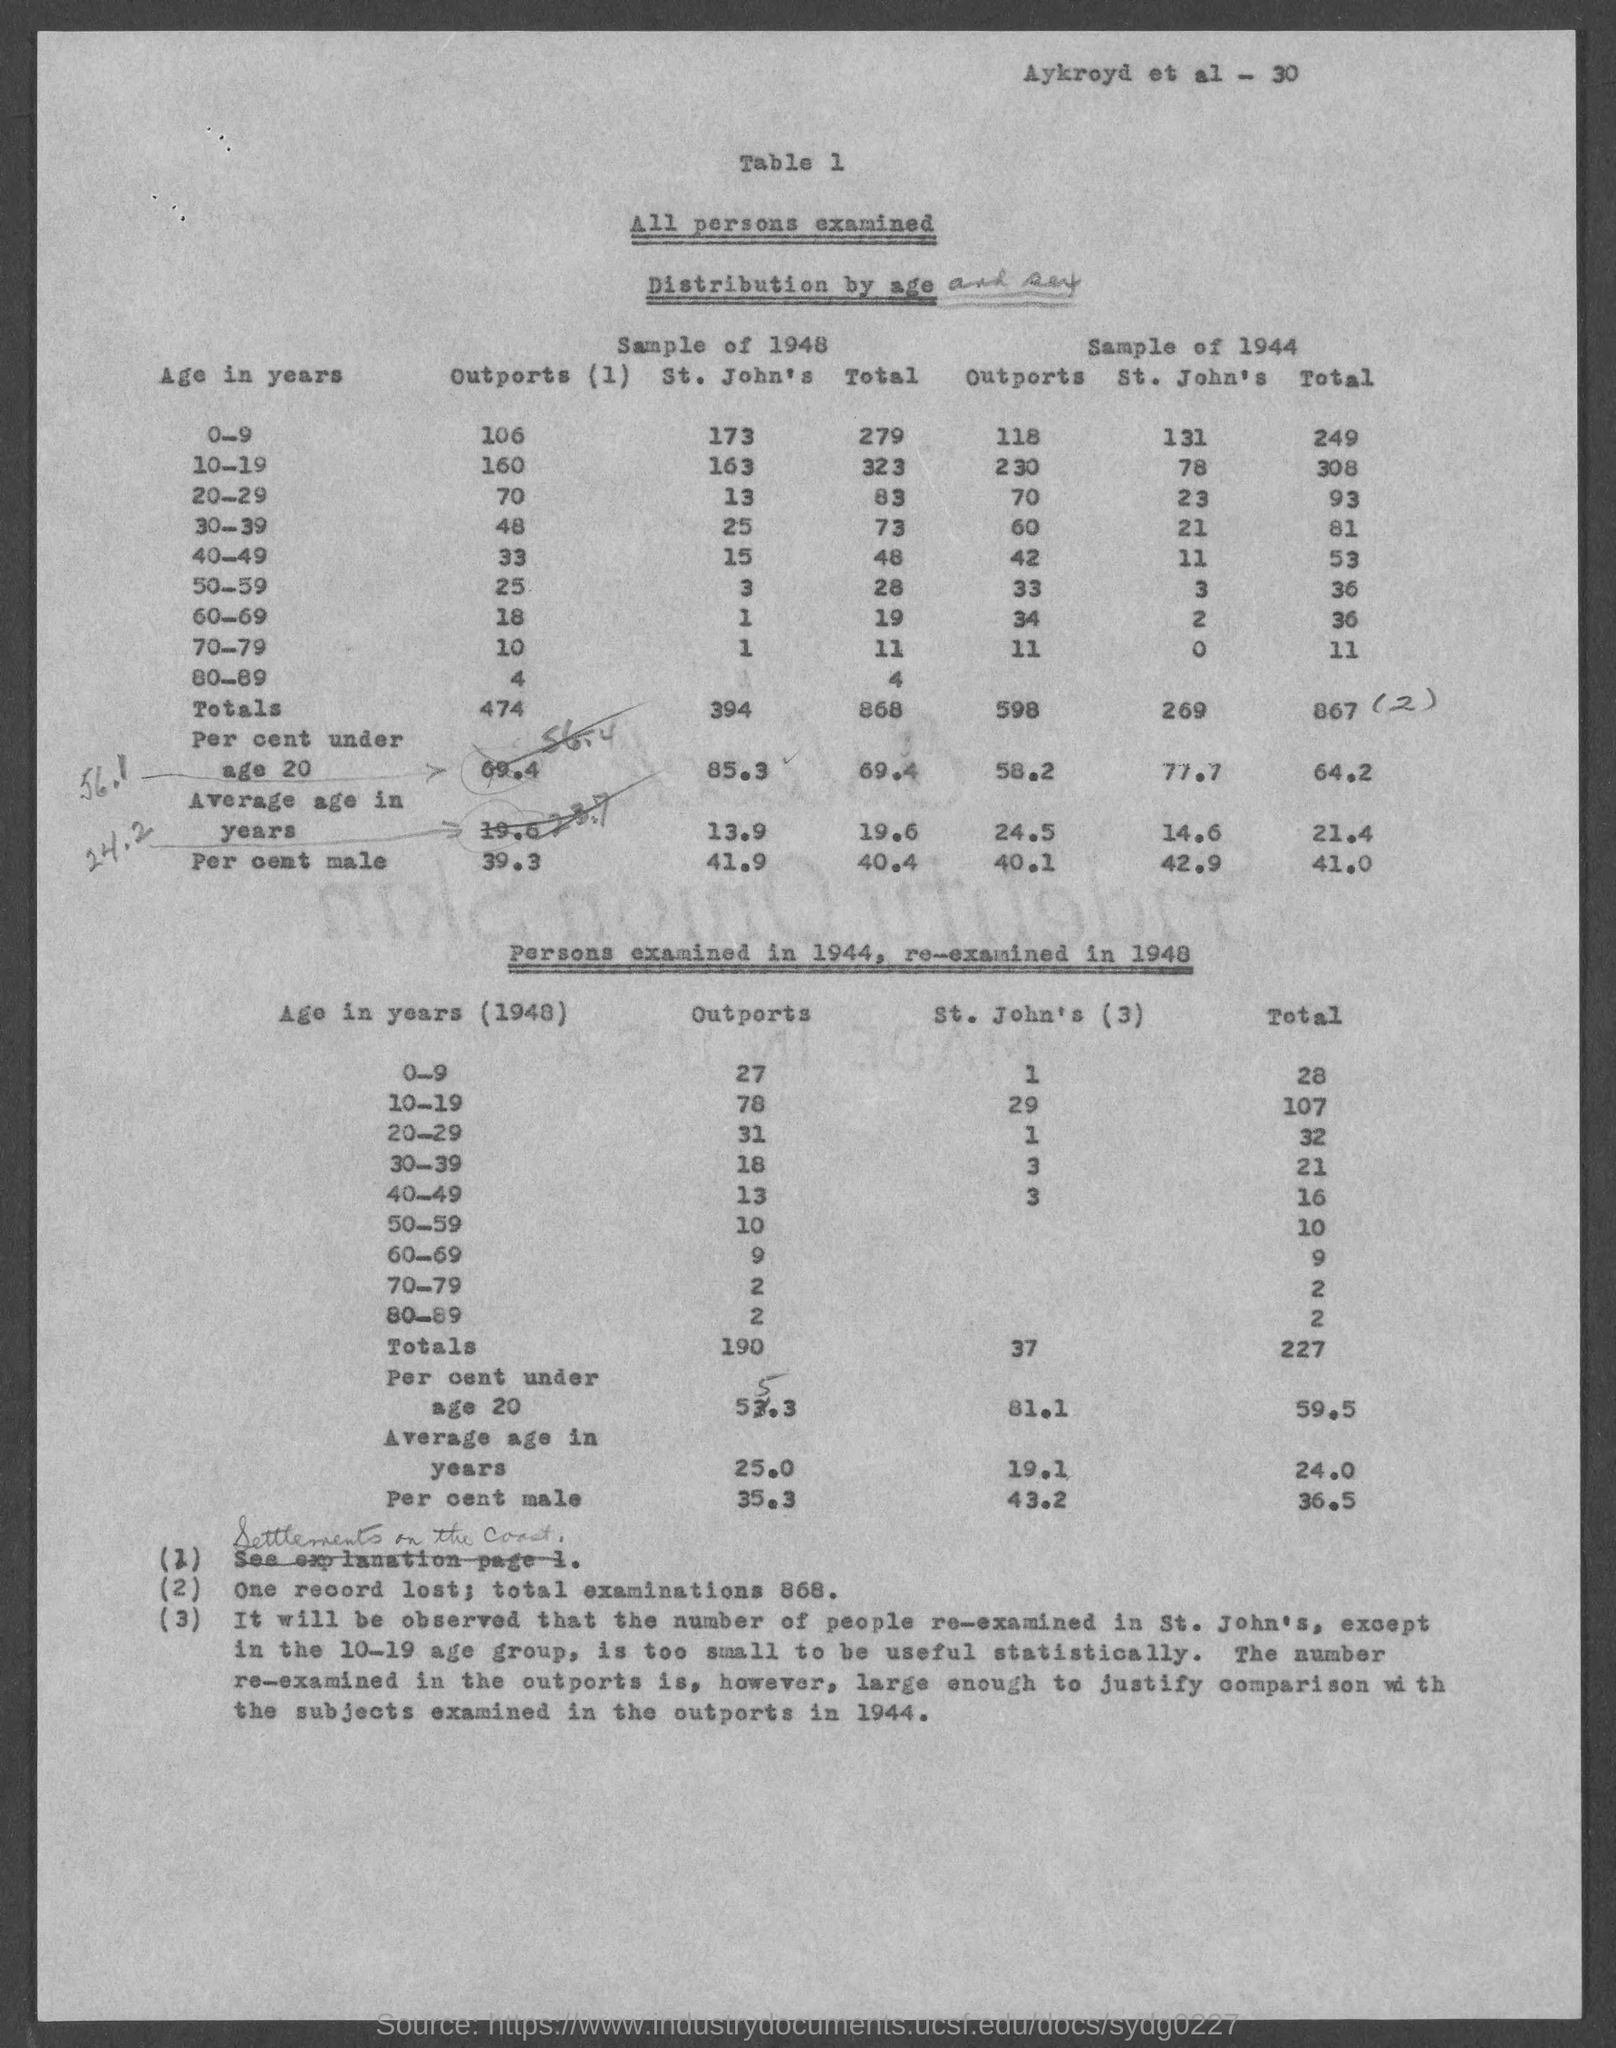What is the total number of examinations ?
Your answer should be compact. 868. 